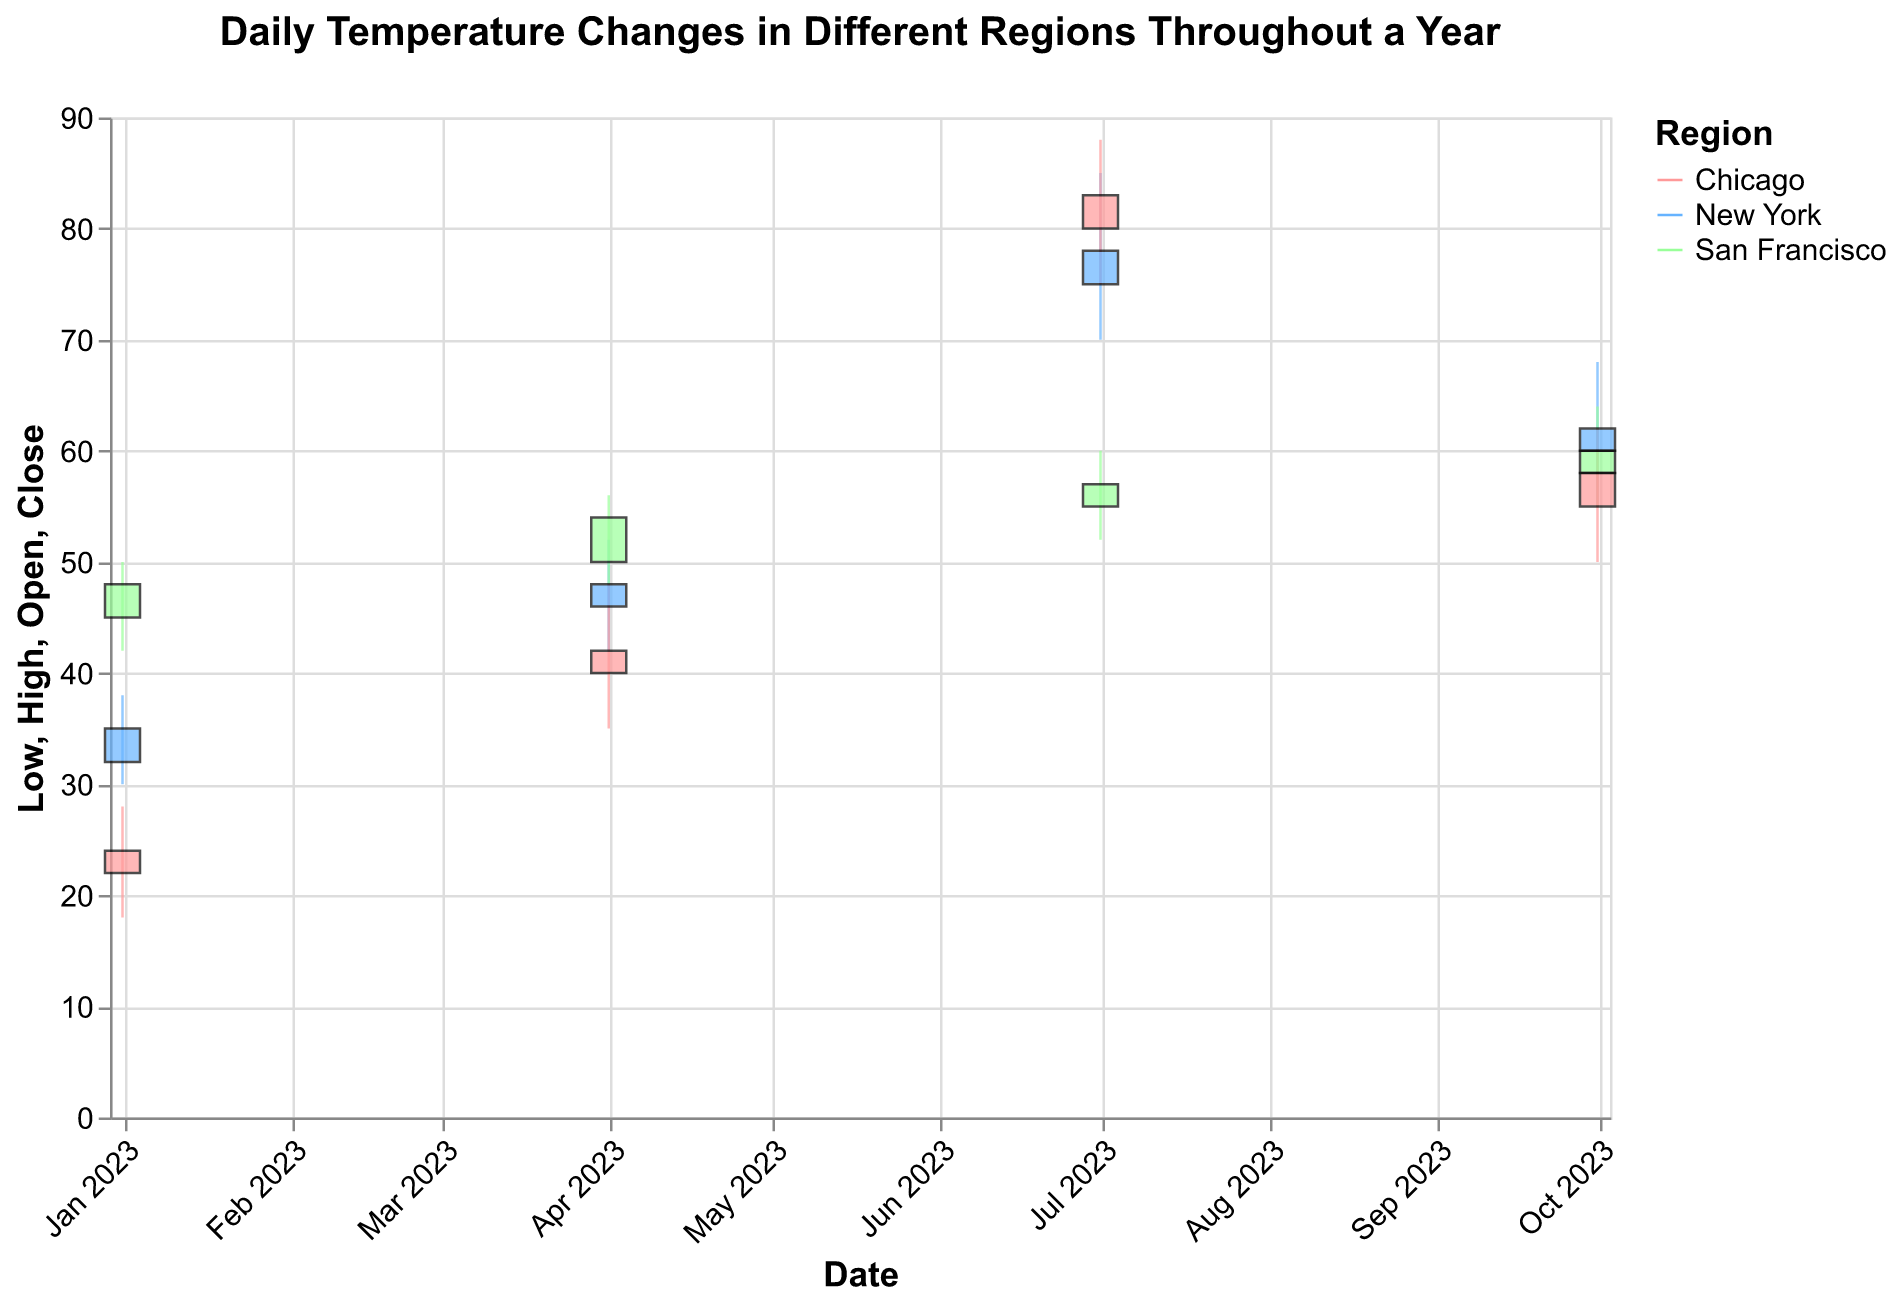What's the title of the plot? The title is displayed prominently at the top of the figure. It reads "Daily Temperature Changes in Different Regions Throughout a Year".
Answer: Daily Temperature Changes in Different Regions Throughout a Year Which region had the highest temperature on July 1, 2023? To find the region with the highest temperature on July 1, 2023, look at the "High" value for that date among the regions. Chicago had the highest with 88 degrees.
Answer: Chicago What's the range of temperatures recorded in New York on January 1, 2023? The range is determined by the "Low" and "High" values. For New York on January 1, 2023, the low was 30 and the high was 38, making the range 38-30=8 degrees.
Answer: 8 degrees Which month shows the greatest temperature variability in Chicago? Temperature variability can be estimated by looking at the difference between the "High" and "Low" values for each month in Chicago. The biggest difference occurs in July with (88-75)=13 degrees.
Answer: July Compare the closing temperatures for all regions on October 1, 2023. Which region recorded the lowest closing temperature? Examine the "Close" values for each region on October 1, 2023. Chicago had the closing temperature of 58, San Francisco had 60, and New York had 62. Chicago had the lowest closing temperature.
Answer: Chicago What is the average closing temperature in San Francisco across all recorded dates? The closing temperatures for San Francisco are 48, 57, 54, and 60. The average is (48 + 57 + 54 + 60) / 4 = 54.75.
Answer: 54.75 Which region had the smallest difference between the open and close temperatures on April 1, 2023? The difference between open and close temperatures can be calculated for each region. For New York, it is (48-46)=2, for San Francisco, it is (54-50)=4, and for Chicago, it is (42-40)=2. New York and Chicago both have the smallest differences.
Answer: New York and Chicago On which date did New York have the highest closing temperature and what was it? Examine the closing temperatures for New York across all dates. The highest closing temperature for New York occurred on July 1, 2023, at 78 degrees.
Answer: July 1, 2023, 78 degrees In which season did San Francisco experience its highest recorded temperature, and what was the value? Identify the season from the dates and compare the high values. The highest recorded temperature in San Francisco was 64 degrees on October 1, 2023, which falls in the fall season.
Answer: Fall, 64 degrees 